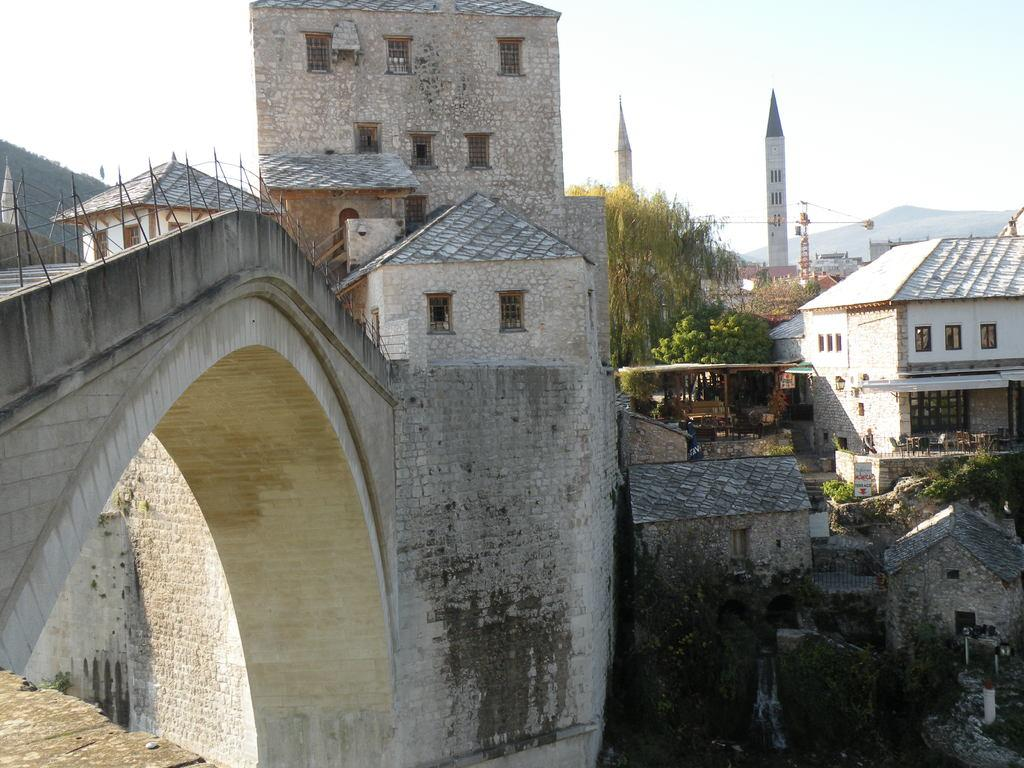What type of structure is the main subject of the image? There is a church in the image. What other types of structures can be seen in the image? There are buildings and monuments in the image. Where is the bridge located in the image? The bridge is on the left side of the image. What natural features are visible in the background of the image? There are mountains visible in the background of the image. What part of the sky is visible in the image? The sky is visible at the top right of the image. What type of zinc is used to construct the bridge in the image? There is no mention of zinc being used in the construction of the bridge in the image. The bridge's material is not specified. 